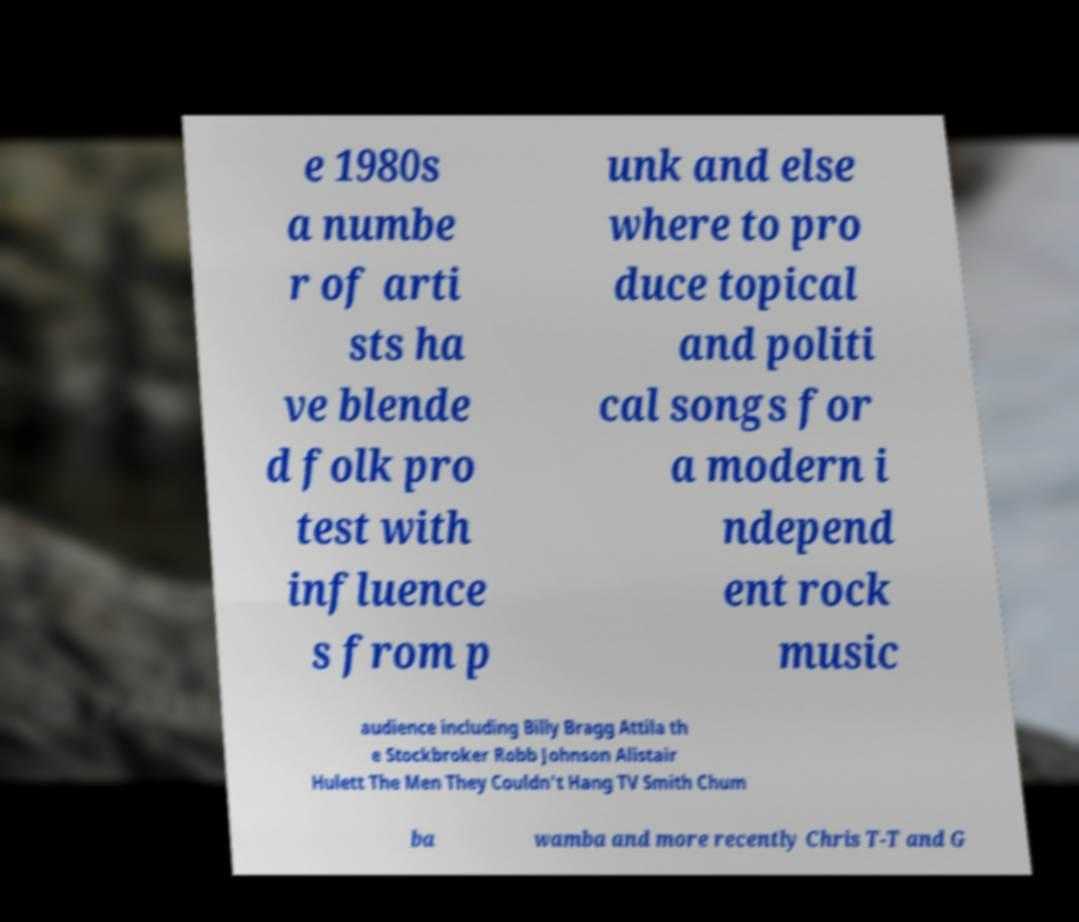Could you extract and type out the text from this image? e 1980s a numbe r of arti sts ha ve blende d folk pro test with influence s from p unk and else where to pro duce topical and politi cal songs for a modern i ndepend ent rock music audience including Billy Bragg Attila th e Stockbroker Robb Johnson Alistair Hulett The Men They Couldn't Hang TV Smith Chum ba wamba and more recently Chris T-T and G 